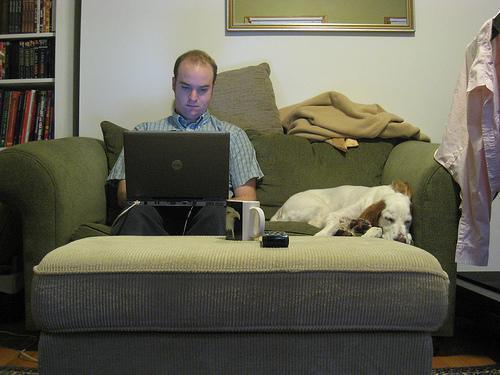How many remote controls are on the ottoman?
Give a very brief answer. 1. How many coffee cups are in the photo?
Give a very brief answer. 1. 